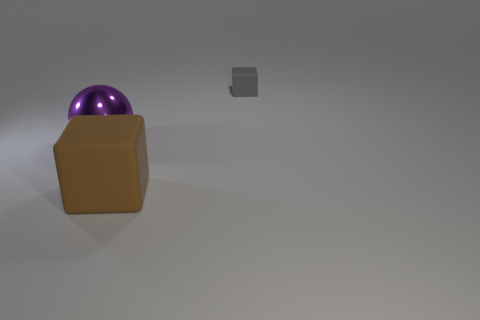Are there fewer large matte blocks than purple rubber spheres?
Your answer should be compact. No. There is a cube that is behind the purple metallic ball; is there a tiny matte block that is on the left side of it?
Make the answer very short. No. Are there any blocks on the right side of the matte thing in front of the rubber object that is behind the brown rubber thing?
Provide a short and direct response. Yes. There is a big object in front of the large purple ball; is it the same shape as the matte object behind the large matte object?
Keep it short and to the point. Yes. What color is the object that is the same material as the small gray cube?
Your response must be concise. Brown. Is the number of shiny things left of the large purple object less than the number of large green balls?
Your answer should be very brief. No. There is a rubber thing behind the thing that is left of the large rubber block that is to the left of the gray matte object; how big is it?
Ensure brevity in your answer.  Small. Do the big object that is to the right of the purple thing and the tiny block have the same material?
Your answer should be very brief. Yes. Is there anything else that is the same shape as the large rubber object?
Keep it short and to the point. Yes. What number of things are purple matte objects or matte blocks?
Provide a succinct answer. 2. 